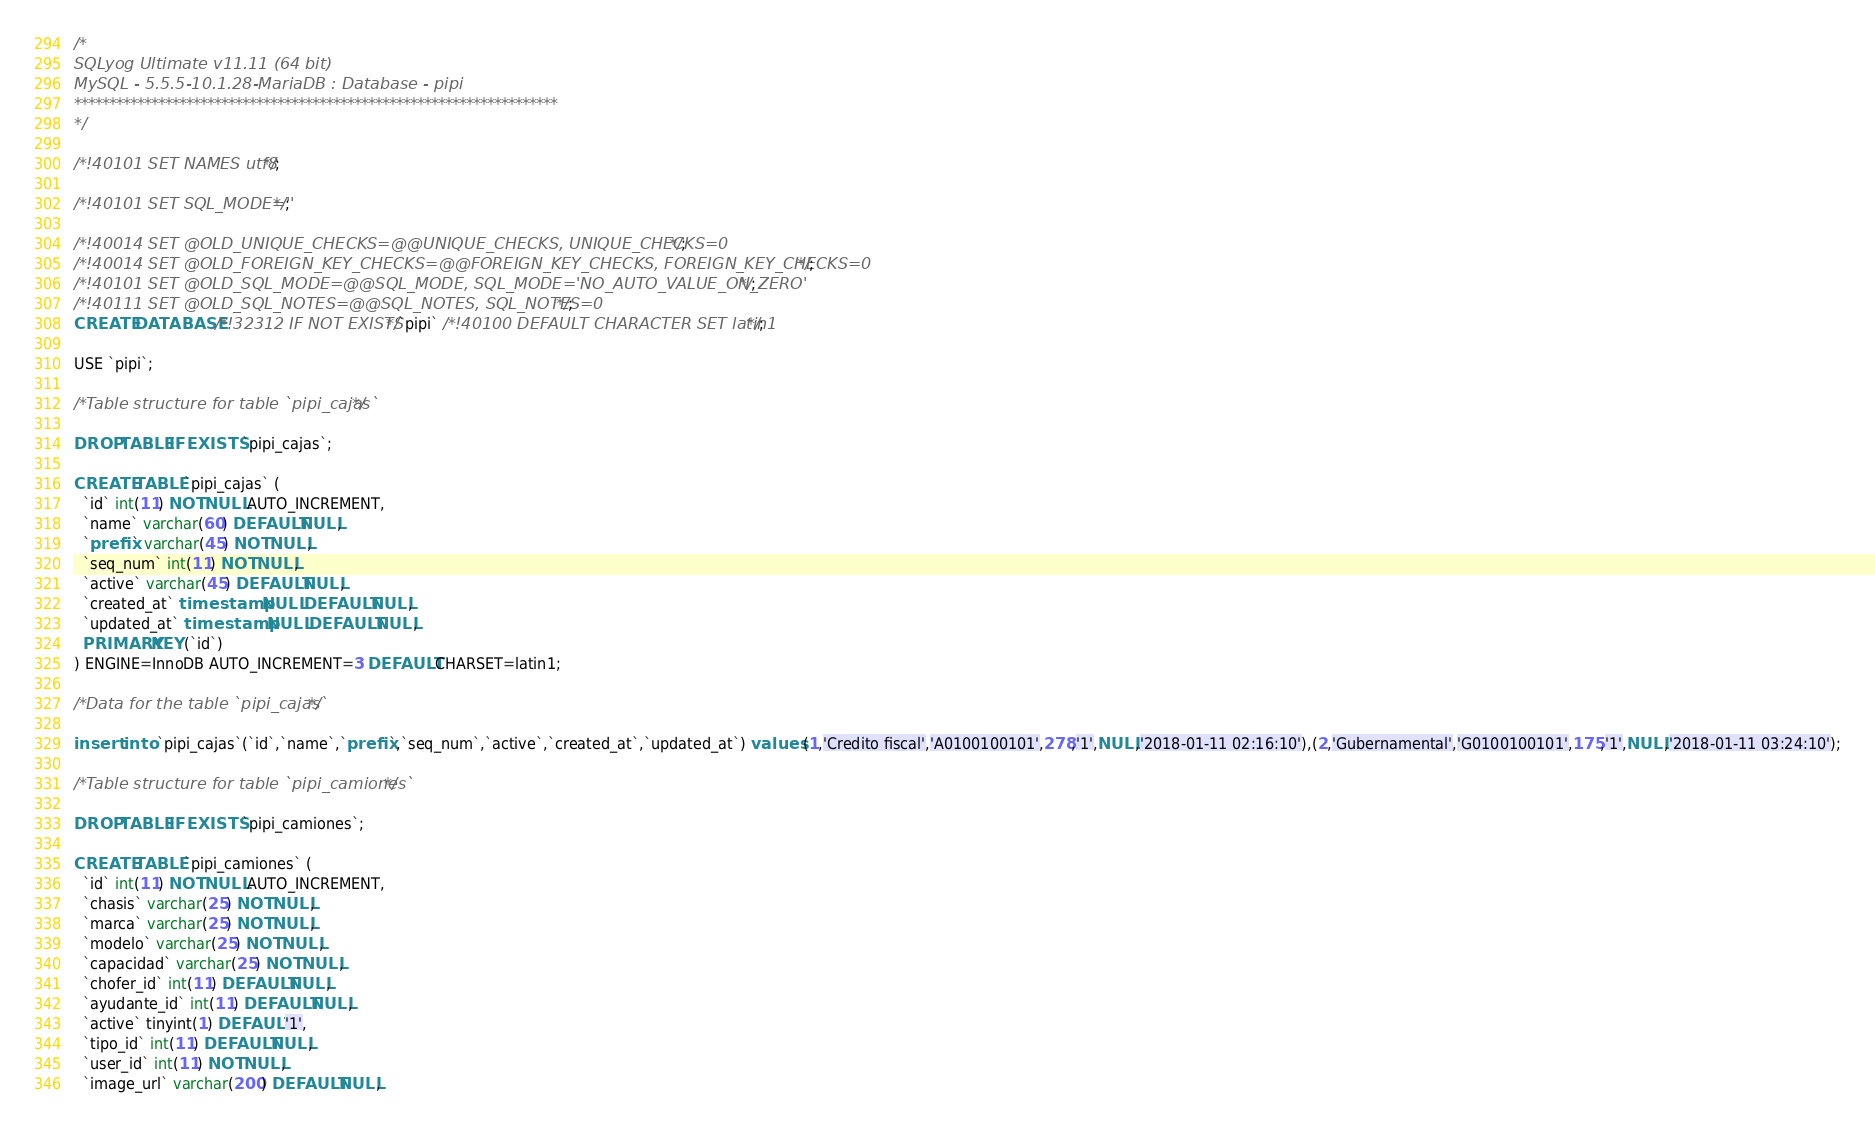<code> <loc_0><loc_0><loc_500><loc_500><_SQL_>/*
SQLyog Ultimate v11.11 (64 bit)
MySQL - 5.5.5-10.1.28-MariaDB : Database - pipi
*********************************************************************
*/

/*!40101 SET NAMES utf8 */;

/*!40101 SET SQL_MODE=''*/;

/*!40014 SET @OLD_UNIQUE_CHECKS=@@UNIQUE_CHECKS, UNIQUE_CHECKS=0 */;
/*!40014 SET @OLD_FOREIGN_KEY_CHECKS=@@FOREIGN_KEY_CHECKS, FOREIGN_KEY_CHECKS=0 */;
/*!40101 SET @OLD_SQL_MODE=@@SQL_MODE, SQL_MODE='NO_AUTO_VALUE_ON_ZERO' */;
/*!40111 SET @OLD_SQL_NOTES=@@SQL_NOTES, SQL_NOTES=0 */;
CREATE DATABASE /*!32312 IF NOT EXISTS*/`pipi` /*!40100 DEFAULT CHARACTER SET latin1 */;

USE `pipi`;

/*Table structure for table `pipi_cajas` */

DROP TABLE IF EXISTS `pipi_cajas`;

CREATE TABLE `pipi_cajas` (
  `id` int(11) NOT NULL AUTO_INCREMENT,
  `name` varchar(60) DEFAULT NULL,
  `prefix` varchar(45) NOT NULL,
  `seq_num` int(11) NOT NULL,
  `active` varchar(45) DEFAULT NULL,
  `created_at` timestamp NULL DEFAULT NULL,
  `updated_at` timestamp NULL DEFAULT NULL,
  PRIMARY KEY (`id`)
) ENGINE=InnoDB AUTO_INCREMENT=3 DEFAULT CHARSET=latin1;

/*Data for the table `pipi_cajas` */

insert  into `pipi_cajas`(`id`,`name`,`prefix`,`seq_num`,`active`,`created_at`,`updated_at`) values (1,'Credito fiscal','A0100100101',278,'1',NULL,'2018-01-11 02:16:10'),(2,'Gubernamental','G0100100101',175,'1',NULL,'2018-01-11 03:24:10');

/*Table structure for table `pipi_camiones` */

DROP TABLE IF EXISTS `pipi_camiones`;

CREATE TABLE `pipi_camiones` (
  `id` int(11) NOT NULL AUTO_INCREMENT,
  `chasis` varchar(25) NOT NULL,
  `marca` varchar(25) NOT NULL,
  `modelo` varchar(25) NOT NULL,
  `capacidad` varchar(25) NOT NULL,
  `chofer_id` int(11) DEFAULT NULL,
  `ayudante_id` int(11) DEFAULT NULL,
  `active` tinyint(1) DEFAULT '1',
  `tipo_id` int(11) DEFAULT NULL,
  `user_id` int(11) NOT NULL,
  `image_url` varchar(200) DEFAULT NULL,</code> 